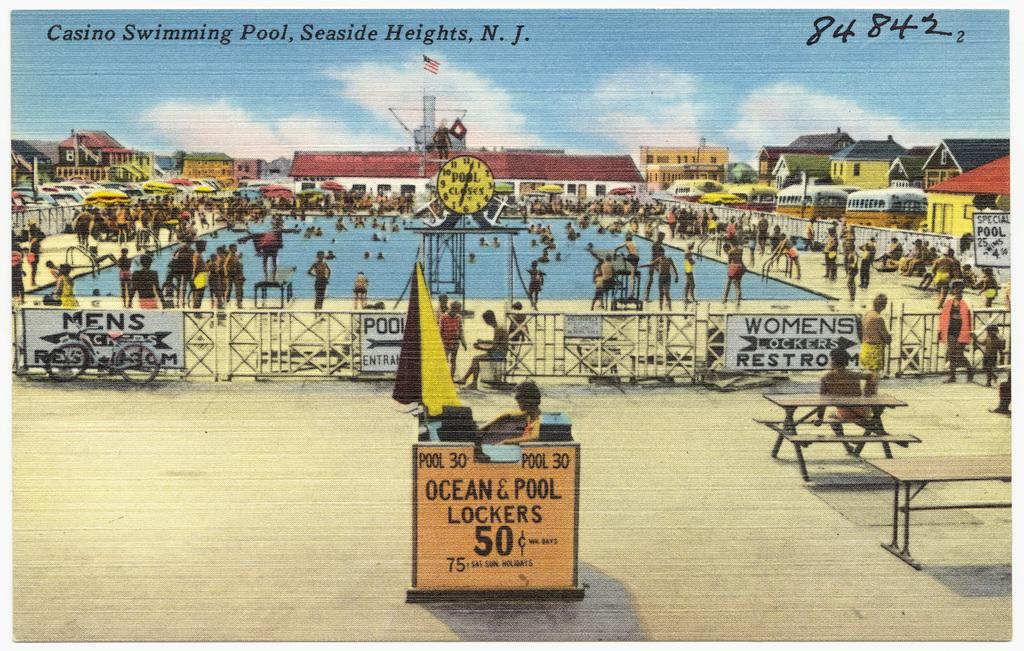<image>
Describe the image concisely. A postcard of Casino Swimming Pool in New Jersey. 